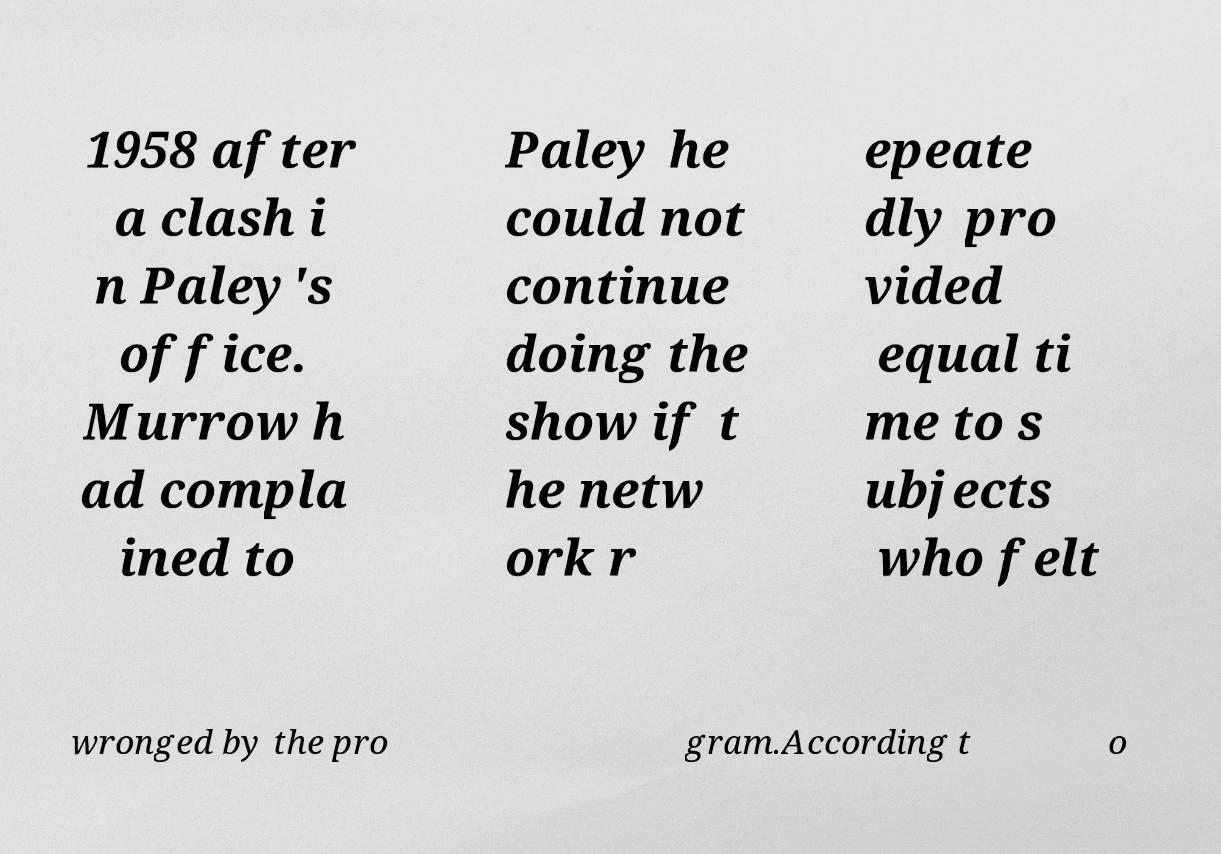For documentation purposes, I need the text within this image transcribed. Could you provide that? 1958 after a clash i n Paley's office. Murrow h ad compla ined to Paley he could not continue doing the show if t he netw ork r epeate dly pro vided equal ti me to s ubjects who felt wronged by the pro gram.According t o 